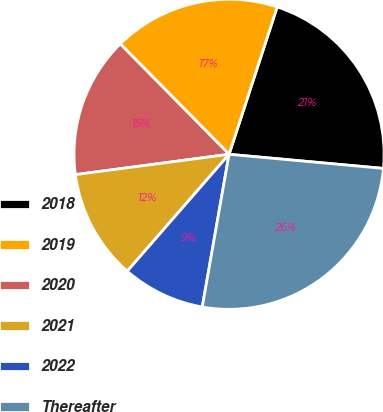Convert chart. <chart><loc_0><loc_0><loc_500><loc_500><pie_chart><fcel>2018<fcel>2019<fcel>2020<fcel>2021<fcel>2022<fcel>Thereafter<nl><fcel>21.43%<fcel>17.41%<fcel>14.71%<fcel>11.5%<fcel>8.64%<fcel>26.31%<nl></chart> 